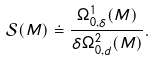Convert formula to latex. <formula><loc_0><loc_0><loc_500><loc_500>\mathcal { S } ( M ) \doteq \frac { \Omega ^ { 1 } _ { 0 , \delta } ( M ) } { \delta \Omega ^ { 2 } _ { 0 , d } ( M ) } .</formula> 